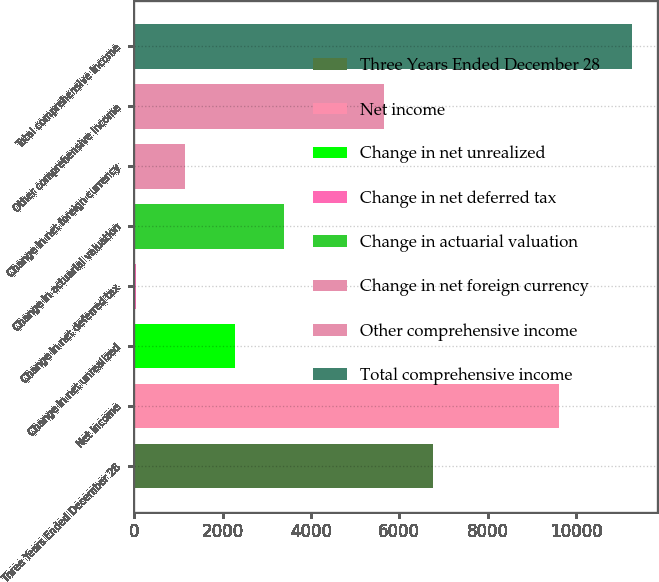<chart> <loc_0><loc_0><loc_500><loc_500><bar_chart><fcel>Three Years Ended December 28<fcel>Net income<fcel>Change in net unrealized<fcel>Change in net deferred tax<fcel>Change in actuarial valuation<fcel>Change in net foreign currency<fcel>Other comprehensive income<fcel>Total comprehensive income<nl><fcel>6767.6<fcel>9620<fcel>2273.2<fcel>26<fcel>3396.8<fcel>1149.6<fcel>5644<fcel>11262<nl></chart> 